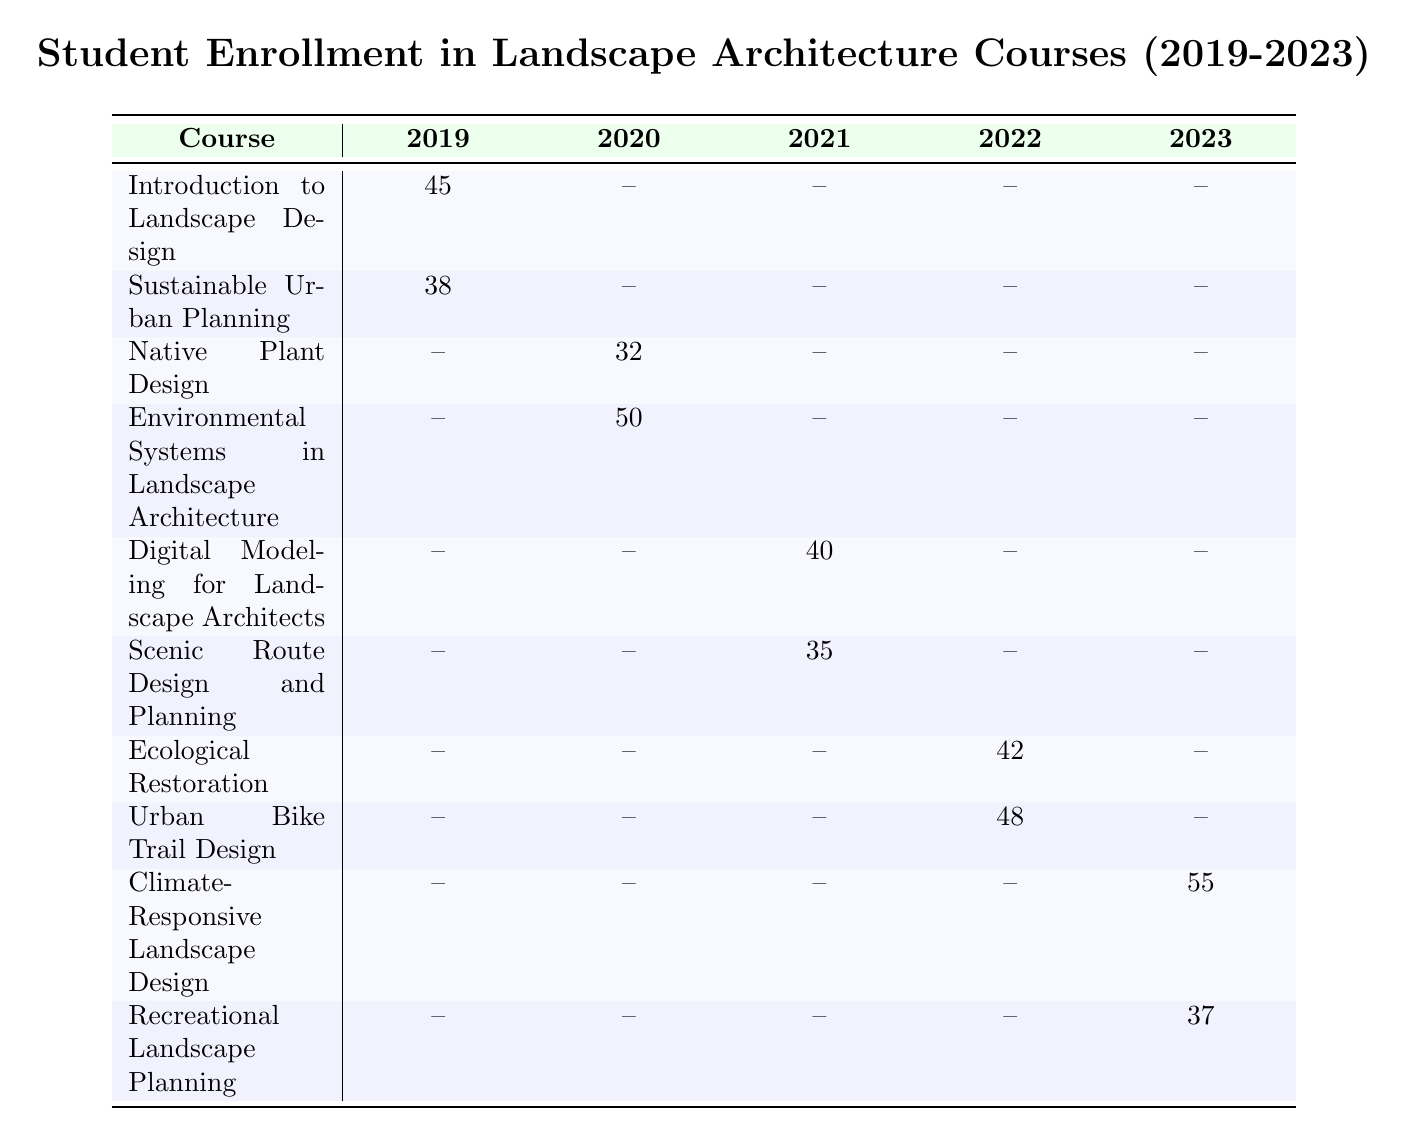What was the enrollment for "Digital Modeling for Landscape Architects" in 2021? The table shows the enrollment for "Digital Modeling for Landscape Architects" under the year 2021, and it indicates an enrollment of 40 students.
Answer: 40 How many students enrolled in "Ecological Restoration" in 2022? The enrollment for "Ecological Restoration" in 2022 is displayed in the table, showing that 42 students enrolled in that course.
Answer: 42 Is the enrollment for "Recreational Landscape Planning" higher than for "Sustainable Urban Planning"? The enrollment for "Recreational Landscape Planning" in 2023 is 37, while for "Sustainable Urban Planning" in 2019 it is 38. Comparing these figures indicates that the enrollment for "Recreational Landscape Planning" is not higher, as 37 is less than 38.
Answer: No What is the total enrollment across all courses in 2022? Referring to the table for the year 2022, the enrollments are Ecological Restoration (42) and Urban Bike Trail Design (48). The sum of these enrollments is 42 + 48 = 90.
Answer: 90 Which course had the highest enrollment in 2023? In 2023, the enrollments for courses are Climate-Responsive Landscape Design (55) and Recreational Landscape Planning (37). Comparing these numbers shows that Climate-Responsive Landscape Design had the highest enrollment with 55 students.
Answer: Climate-Responsive Landscape Design What was the average enrollment for courses in 2020? For 2020, the courses listed are Native Plant Design (32) and Environmental Systems in Landscape Architecture (50). To find the average, sum the enrollments: 32 + 50 = 82. Then divide by the number of courses: 82 / 2 = 41.
Answer: 41 Did Cornell University offer a course in both 2019 and 2023? The table indicates that Cornell University offered "Introduction to Landscape Design" in 2019 but does not list any courses for Cornell University in 2023. Therefore, the answer is no.
Answer: No What is the difference in enrollment between the course with the highest enrollment in 2019 and the course with the highest enrollment in 2022? In 2019, the highest enrollment was 45 for "Introduction to Landscape Design." In 2022, "Urban Bike Trail Design" had 48 students. The difference is 48 - 45 = 3.
Answer: 3 Which semester had the highest total enrollment across all courses? Analyzing the table, the fall semesters had the following enrollments: 45 (2019), 32 (2020), 40 (2021), 42 (2022), and 55 (2023), giving a total of 45 + 32 + 40 + 42 + 55 = 214. The spring semesters had 38 (2019), 50 (2020), 35 (2021), 48 (2022), and 37 (2023), totaling 38 + 50 + 35 + 48 + 37 = 208. Thus, fall has higher enrollment.
Answer: Fall 